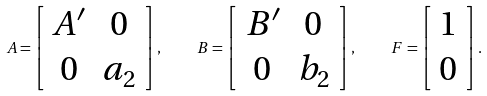Convert formula to latex. <formula><loc_0><loc_0><loc_500><loc_500>A = \left [ \begin{array} { c c } A ^ { \prime } & 0 \\ 0 & a _ { 2 } \end{array} \right ] , \quad B = \left [ \begin{array} { c c } B ^ { \prime } & 0 \\ 0 & b _ { 2 } \end{array} \right ] , \quad F = \left [ \begin{array} { c } 1 \\ 0 \end{array} \right ] .</formula> 